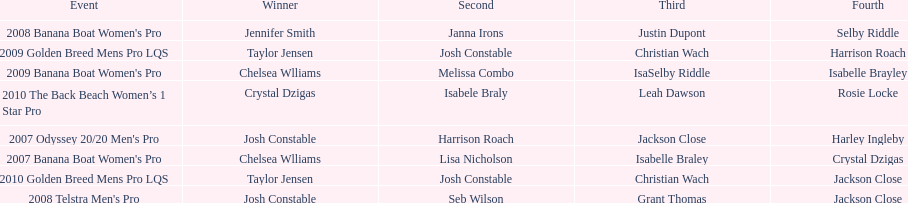Could you parse the entire table? {'header': ['Event', 'Winner', 'Second', 'Third', 'Fourth'], 'rows': [["2008 Banana Boat Women's Pro", 'Jennifer Smith', 'Janna Irons', 'Justin Dupont', 'Selby Riddle'], ['2009 Golden Breed Mens Pro LQS', 'Taylor Jensen', 'Josh Constable', 'Christian Wach', 'Harrison Roach'], ["2009 Banana Boat Women's Pro", 'Chelsea Wlliams', 'Melissa Combo', 'IsaSelby Riddle', 'Isabelle Brayley'], ['2010 The Back Beach Women’s 1 Star Pro', 'Crystal Dzigas', 'Isabele Braly', 'Leah Dawson', 'Rosie Locke'], ["2007 Odyssey 20/20 Men's Pro", 'Josh Constable', 'Harrison Roach', 'Jackson Close', 'Harley Ingleby'], ["2007 Banana Boat Women's Pro", 'Chelsea Wlliams', 'Lisa Nicholson', 'Isabelle Braley', 'Crystal Dzigas'], ['2010 Golden Breed Mens Pro LQS', 'Taylor Jensen', 'Josh Constable', 'Christian Wach', 'Jackson Close'], ["2008 Telstra Men's Pro", 'Josh Constable', 'Seb Wilson', 'Grant Thomas', 'Jackson Close']]} How many times was josh constable second? 2. 